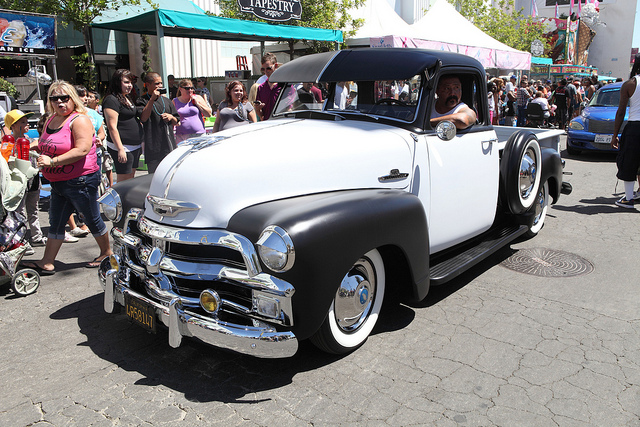<image>What is the make of the truck? I am not sure about the make of the truck. However, possibilities include 'chrysler', 'chevy' or 'ford'. What is the make of the truck? I am not sure what the make of the truck is. It can be seen as 'chrysler', 'chevy', 'metal', 'unknown', or 'ford'. 